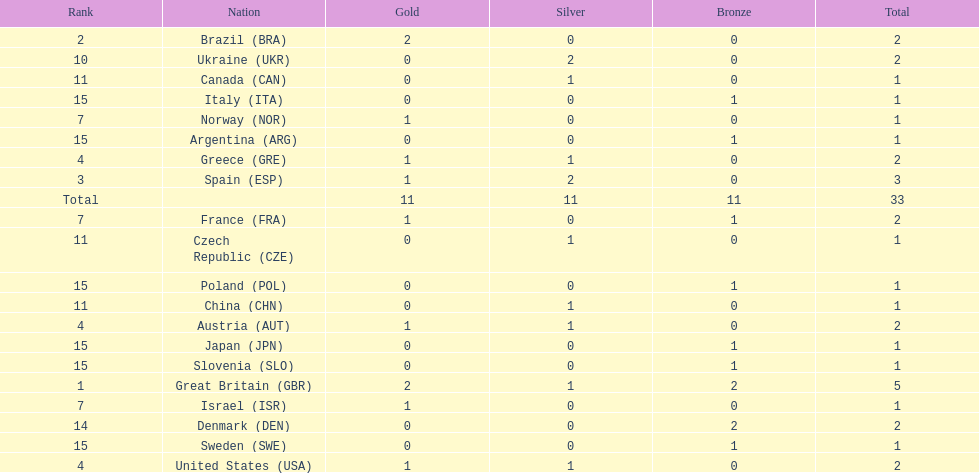What country had the most medals? Great Britain. 